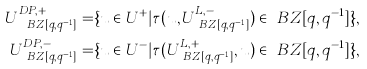<formula> <loc_0><loc_0><loc_500><loc_500>U _ { \ B Z [ q , q ^ { - 1 } ] } ^ { D P , + } = & \{ u \in U ^ { + } | \tau ( u , U _ { \ B Z [ q , q ^ { - 1 } ] } ^ { L , - } ) \in \ B Z [ q , q ^ { - 1 } ] \} , \\ U _ { \ B Z [ q , q ^ { - 1 } ] } ^ { D P , - } = & \{ u \in U ^ { - } | \tau ( U _ { \ B Z [ q , q ^ { - 1 } ] } ^ { L , + } , u ) \in \ B Z [ q , q ^ { - 1 } ] \} ,</formula> 